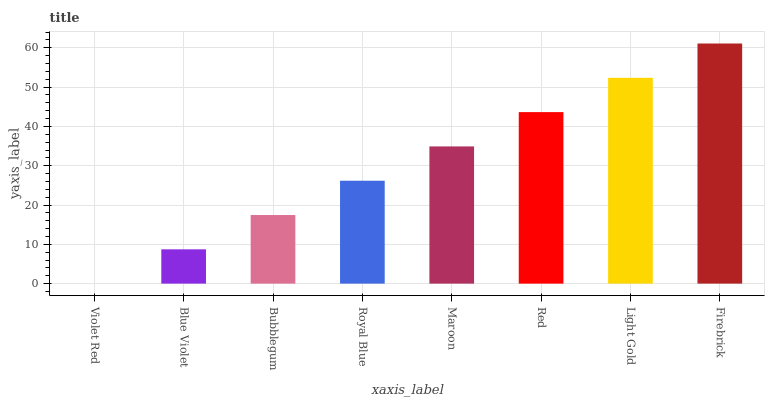Is Violet Red the minimum?
Answer yes or no. Yes. Is Firebrick the maximum?
Answer yes or no. Yes. Is Blue Violet the minimum?
Answer yes or no. No. Is Blue Violet the maximum?
Answer yes or no. No. Is Blue Violet greater than Violet Red?
Answer yes or no. Yes. Is Violet Red less than Blue Violet?
Answer yes or no. Yes. Is Violet Red greater than Blue Violet?
Answer yes or no. No. Is Blue Violet less than Violet Red?
Answer yes or no. No. Is Maroon the high median?
Answer yes or no. Yes. Is Royal Blue the low median?
Answer yes or no. Yes. Is Red the high median?
Answer yes or no. No. Is Red the low median?
Answer yes or no. No. 